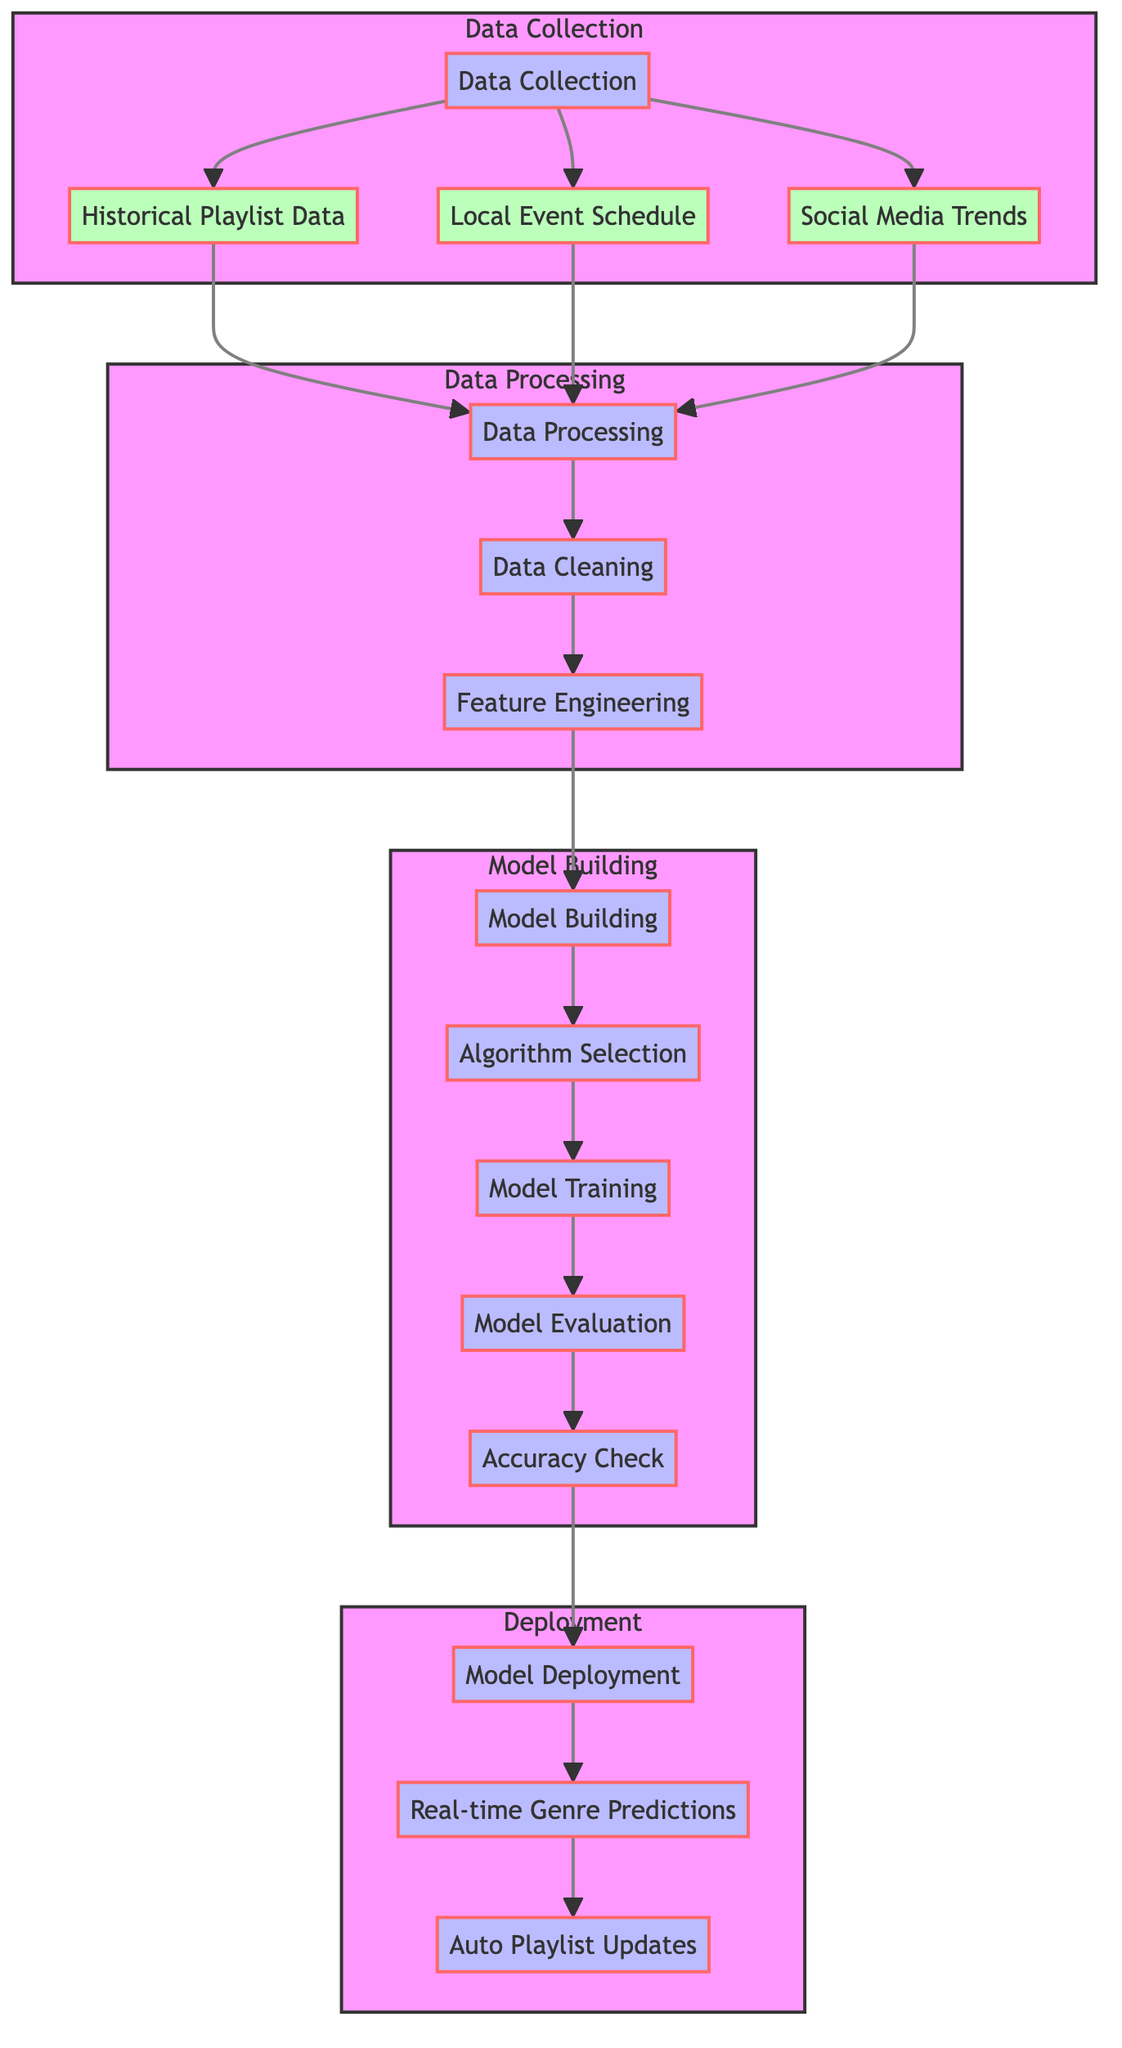What are the three data sources used in this model? The diagram shows three data sources: Historical Playlist Data, Local Event Schedule, and Social Media Trends. These are listed under the Data Collection subgraph.
Answer: Historical Playlist Data, Local Event Schedule, Social Media Trends How many subgraphs are there in the diagram? The diagram consists of four subgraphs: Data Collection, Data Processing, Model Building, and Deployment. Counting these gives us the number of subgraphs.
Answer: Four Which process follows Data Cleaning? The diagram shows that after Data Cleaning, the next step is Feature Engineering. This relationship is indicated by the directed edge from Data Cleaning to Feature Engineering in the Data Processing subgraph.
Answer: Feature Engineering How many total processes are involved in Model Building? The Model Building subgraph contains four processes: Algorithm Selection, Model Training, Model Evaluation, and Accuracy Check. By counting these, we find the total number of processes in this part of the diagram.
Answer: Four What is the final output of the model deployment process? In the Deployment subgraph, Real-time Genre Predictions leads to Auto Playlist Updates, indicating that the output of the deployment is the auto updates of the playlist based on predictions. Therefore, the final output is Auto Playlist Updates.
Answer: Auto Playlist Updates What is the purpose of the model evaluation process? The purpose of Model Evaluation is to assess the performance of the trained model, which is a typical step in machine learning workflows. It comes before the Accuracy Check in the sequential flow of processes in the Model Building subgraph.
Answer: Assess performance Which node indicates the flow of data to model training? The Feature Engineering node directly leads to the Model Building subgraph and is one step before Model Training, making it the node indicating the flow of cleaned and processed data to training the model.
Answer: Feature Engineering Which subgraph contains the step for data cleaning? The Data Processing subgraph contains the step for Data Cleaning, as seen in the sequence of processes illustrated under that specific subgraph in the diagram.
Answer: Data Processing 